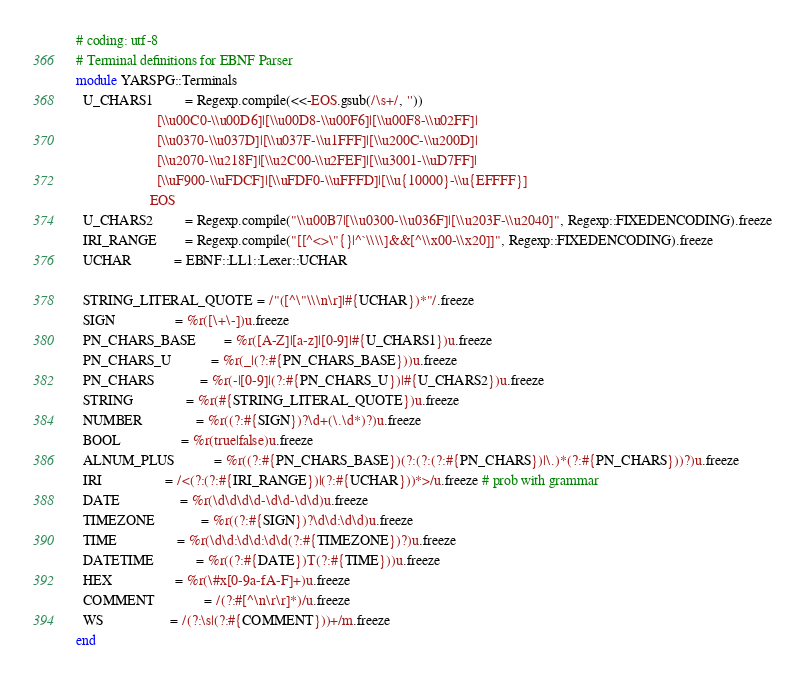Convert code to text. <code><loc_0><loc_0><loc_500><loc_500><_Ruby_># coding: utf-8
# Terminal definitions for EBNF Parser
module YARSPG::Terminals
  U_CHARS1         = Regexp.compile(<<-EOS.gsub(/\s+/, ''))
                       [\\u00C0-\\u00D6]|[\\u00D8-\\u00F6]|[\\u00F8-\\u02FF]|
                       [\\u0370-\\u037D]|[\\u037F-\\u1FFF]|[\\u200C-\\u200D]|
                       [\\u2070-\\u218F]|[\\u2C00-\\u2FEF]|[\\u3001-\\uD7FF]|
                       [\\uF900-\\uFDCF]|[\\uFDF0-\\uFFFD]|[\\u{10000}-\\u{EFFFF}]
                     EOS
  U_CHARS2         = Regexp.compile("\\u00B7|[\\u0300-\\u036F]|[\\u203F-\\u2040]", Regexp::FIXEDENCODING).freeze
  IRI_RANGE        = Regexp.compile("[[^<>\"{}|^`\\\\]&&[^\\x00-\\x20]]", Regexp::FIXEDENCODING).freeze
  UCHAR            = EBNF::LL1::Lexer::UCHAR

  STRING_LITERAL_QUOTE = /"([^\"\\\n\r]|#{UCHAR})*"/.freeze
  SIGN                 = %r([\+\-])u.freeze
  PN_CHARS_BASE        = %r([A-Z]|[a-z]|[0-9]|#{U_CHARS1})u.freeze
  PN_CHARS_U           = %r(_|(?:#{PN_CHARS_BASE}))u.freeze
  PN_CHARS             = %r(-|[0-9]|(?:#{PN_CHARS_U})|#{U_CHARS2})u.freeze
  STRING               = %r(#{STRING_LITERAL_QUOTE})u.freeze
  NUMBER               = %r((?:#{SIGN})?\d+(\.\d*)?)u.freeze
  BOOL                 = %r(true|false)u.freeze
  ALNUM_PLUS           = %r((?:#{PN_CHARS_BASE})(?:(?:(?:#{PN_CHARS})|\.)*(?:#{PN_CHARS}))?)u.freeze
  IRI                  = /<(?:(?:#{IRI_RANGE})|(?:#{UCHAR}))*>/u.freeze # prob with grammar
  DATE                 = %r(\d\d\d\d-\d\d-\d\d)u.freeze
  TIMEZONE             = %r((?:#{SIGN})?\d\d:\d\d)u.freeze
  TIME                 = %r(\d\d:\d\d:\d\d(?:#{TIMEZONE})?)u.freeze
  DATETIME            = %r((?:#{DATE})T(?:#{TIME}))u.freeze
  HEX                  = %r(\#x[0-9a-fA-F]+)u.freeze
  COMMENT              = /(?:#[^\n\r\r]*)/u.freeze
  WS                   = /(?:\s|(?:#{COMMENT}))+/m.freeze
end
</code> 